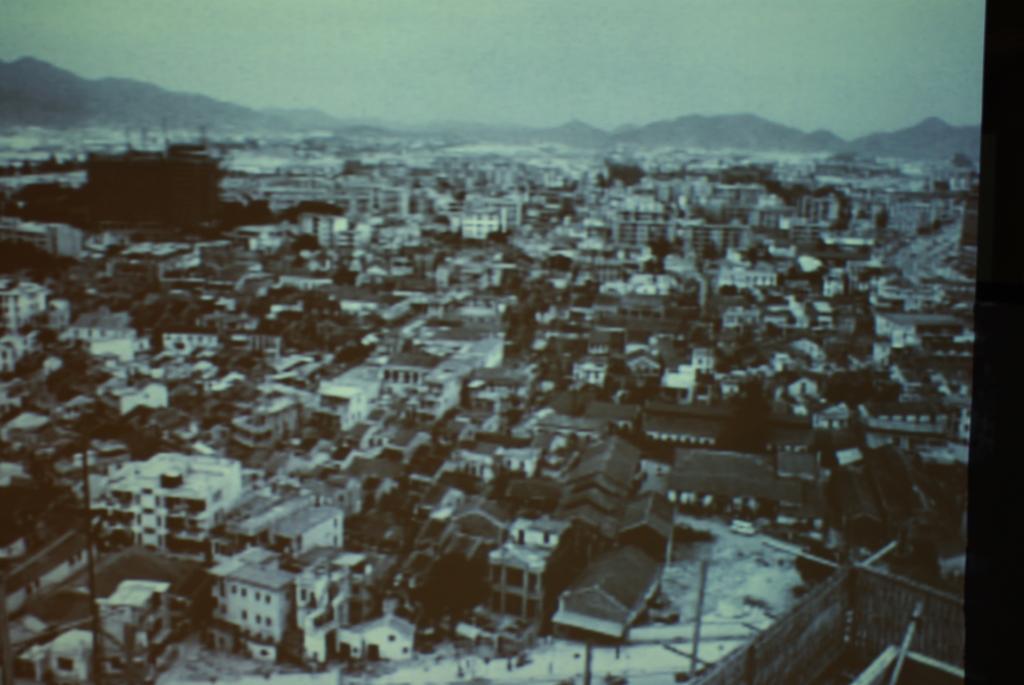Can you describe this image briefly? This is a black and white photography. In the photograph we can see buildings, trees, roads, railings, poles, hills and sky. 